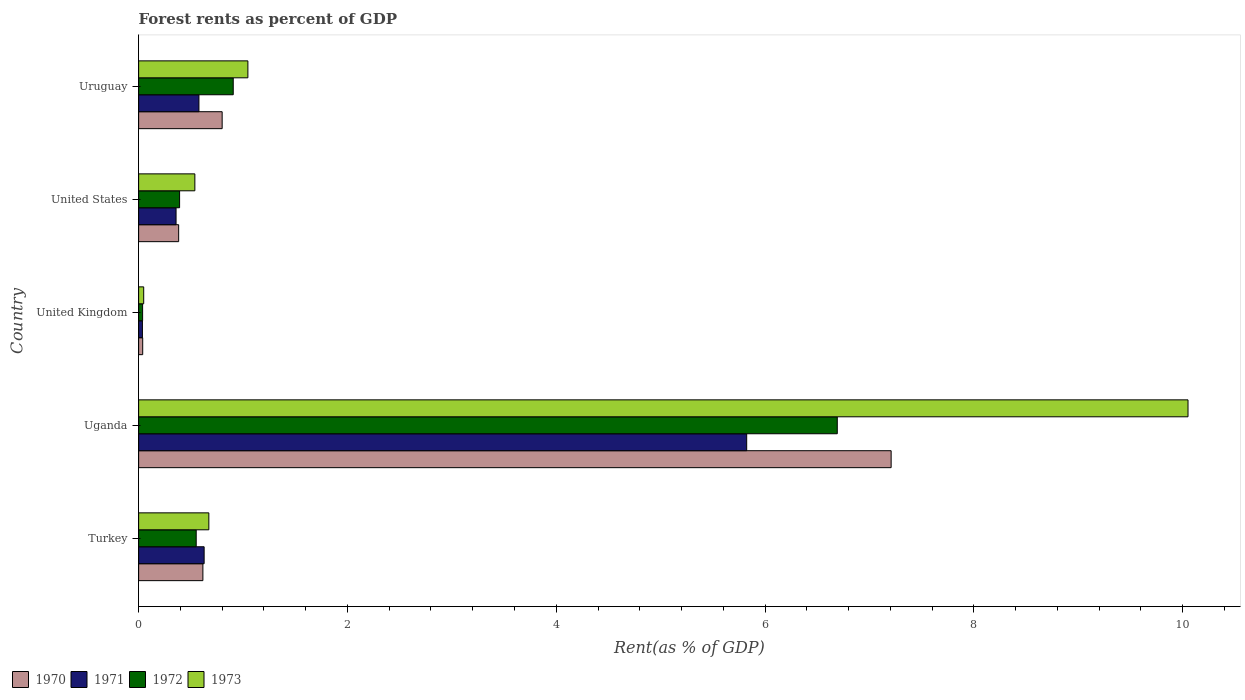How many different coloured bars are there?
Ensure brevity in your answer.  4. How many groups of bars are there?
Provide a succinct answer. 5. Are the number of bars per tick equal to the number of legend labels?
Ensure brevity in your answer.  Yes. Are the number of bars on each tick of the Y-axis equal?
Provide a short and direct response. Yes. How many bars are there on the 4th tick from the top?
Your answer should be compact. 4. How many bars are there on the 3rd tick from the bottom?
Keep it short and to the point. 4. What is the forest rent in 1973 in United Kingdom?
Provide a short and direct response. 0.05. Across all countries, what is the maximum forest rent in 1970?
Your answer should be compact. 7.21. Across all countries, what is the minimum forest rent in 1973?
Your answer should be compact. 0.05. In which country was the forest rent in 1971 maximum?
Your answer should be compact. Uganda. What is the total forest rent in 1973 in the graph?
Keep it short and to the point. 12.36. What is the difference between the forest rent in 1971 in United Kingdom and that in United States?
Ensure brevity in your answer.  -0.32. What is the difference between the forest rent in 1970 in United States and the forest rent in 1973 in Uruguay?
Offer a terse response. -0.66. What is the average forest rent in 1973 per country?
Offer a terse response. 2.47. What is the difference between the forest rent in 1970 and forest rent in 1972 in Uruguay?
Provide a short and direct response. -0.11. In how many countries, is the forest rent in 1971 greater than 7.6 %?
Offer a very short reply. 0. What is the ratio of the forest rent in 1971 in Uganda to that in United States?
Your answer should be compact. 16.24. What is the difference between the highest and the second highest forest rent in 1970?
Keep it short and to the point. 6.41. What is the difference between the highest and the lowest forest rent in 1970?
Keep it short and to the point. 7.17. Is it the case that in every country, the sum of the forest rent in 1970 and forest rent in 1971 is greater than the forest rent in 1973?
Provide a succinct answer. Yes. What is the difference between two consecutive major ticks on the X-axis?
Offer a terse response. 2. Are the values on the major ticks of X-axis written in scientific E-notation?
Provide a succinct answer. No. Where does the legend appear in the graph?
Your answer should be compact. Bottom left. How many legend labels are there?
Provide a succinct answer. 4. How are the legend labels stacked?
Your answer should be compact. Horizontal. What is the title of the graph?
Keep it short and to the point. Forest rents as percent of GDP. What is the label or title of the X-axis?
Offer a very short reply. Rent(as % of GDP). What is the Rent(as % of GDP) in 1970 in Turkey?
Give a very brief answer. 0.62. What is the Rent(as % of GDP) of 1971 in Turkey?
Offer a terse response. 0.63. What is the Rent(as % of GDP) of 1972 in Turkey?
Provide a succinct answer. 0.55. What is the Rent(as % of GDP) in 1973 in Turkey?
Your answer should be very brief. 0.67. What is the Rent(as % of GDP) of 1970 in Uganda?
Make the answer very short. 7.21. What is the Rent(as % of GDP) of 1971 in Uganda?
Give a very brief answer. 5.82. What is the Rent(as % of GDP) of 1972 in Uganda?
Your answer should be very brief. 6.69. What is the Rent(as % of GDP) of 1973 in Uganda?
Ensure brevity in your answer.  10.05. What is the Rent(as % of GDP) in 1970 in United Kingdom?
Ensure brevity in your answer.  0.04. What is the Rent(as % of GDP) of 1971 in United Kingdom?
Your response must be concise. 0.04. What is the Rent(as % of GDP) in 1972 in United Kingdom?
Your answer should be compact. 0.04. What is the Rent(as % of GDP) in 1973 in United Kingdom?
Ensure brevity in your answer.  0.05. What is the Rent(as % of GDP) in 1970 in United States?
Your answer should be very brief. 0.38. What is the Rent(as % of GDP) of 1971 in United States?
Provide a succinct answer. 0.36. What is the Rent(as % of GDP) in 1972 in United States?
Your answer should be compact. 0.39. What is the Rent(as % of GDP) in 1973 in United States?
Ensure brevity in your answer.  0.54. What is the Rent(as % of GDP) of 1970 in Uruguay?
Keep it short and to the point. 0.8. What is the Rent(as % of GDP) in 1971 in Uruguay?
Ensure brevity in your answer.  0.58. What is the Rent(as % of GDP) of 1972 in Uruguay?
Offer a terse response. 0.91. What is the Rent(as % of GDP) of 1973 in Uruguay?
Your answer should be compact. 1.05. Across all countries, what is the maximum Rent(as % of GDP) of 1970?
Offer a very short reply. 7.21. Across all countries, what is the maximum Rent(as % of GDP) in 1971?
Offer a very short reply. 5.82. Across all countries, what is the maximum Rent(as % of GDP) in 1972?
Ensure brevity in your answer.  6.69. Across all countries, what is the maximum Rent(as % of GDP) of 1973?
Ensure brevity in your answer.  10.05. Across all countries, what is the minimum Rent(as % of GDP) of 1970?
Offer a terse response. 0.04. Across all countries, what is the minimum Rent(as % of GDP) in 1971?
Your answer should be very brief. 0.04. Across all countries, what is the minimum Rent(as % of GDP) in 1972?
Provide a short and direct response. 0.04. Across all countries, what is the minimum Rent(as % of GDP) of 1973?
Give a very brief answer. 0.05. What is the total Rent(as % of GDP) of 1970 in the graph?
Your answer should be very brief. 9.04. What is the total Rent(as % of GDP) of 1971 in the graph?
Offer a terse response. 7.42. What is the total Rent(as % of GDP) of 1972 in the graph?
Make the answer very short. 8.58. What is the total Rent(as % of GDP) of 1973 in the graph?
Offer a terse response. 12.36. What is the difference between the Rent(as % of GDP) of 1970 in Turkey and that in Uganda?
Offer a very short reply. -6.59. What is the difference between the Rent(as % of GDP) in 1971 in Turkey and that in Uganda?
Your answer should be very brief. -5.2. What is the difference between the Rent(as % of GDP) in 1972 in Turkey and that in Uganda?
Offer a terse response. -6.14. What is the difference between the Rent(as % of GDP) of 1973 in Turkey and that in Uganda?
Give a very brief answer. -9.38. What is the difference between the Rent(as % of GDP) of 1970 in Turkey and that in United Kingdom?
Your response must be concise. 0.58. What is the difference between the Rent(as % of GDP) of 1971 in Turkey and that in United Kingdom?
Offer a very short reply. 0.59. What is the difference between the Rent(as % of GDP) in 1972 in Turkey and that in United Kingdom?
Provide a succinct answer. 0.51. What is the difference between the Rent(as % of GDP) of 1973 in Turkey and that in United Kingdom?
Ensure brevity in your answer.  0.62. What is the difference between the Rent(as % of GDP) in 1970 in Turkey and that in United States?
Offer a very short reply. 0.23. What is the difference between the Rent(as % of GDP) in 1971 in Turkey and that in United States?
Your answer should be compact. 0.27. What is the difference between the Rent(as % of GDP) of 1972 in Turkey and that in United States?
Your answer should be compact. 0.16. What is the difference between the Rent(as % of GDP) in 1973 in Turkey and that in United States?
Offer a terse response. 0.13. What is the difference between the Rent(as % of GDP) in 1970 in Turkey and that in Uruguay?
Give a very brief answer. -0.18. What is the difference between the Rent(as % of GDP) in 1971 in Turkey and that in Uruguay?
Provide a succinct answer. 0.05. What is the difference between the Rent(as % of GDP) in 1972 in Turkey and that in Uruguay?
Offer a terse response. -0.35. What is the difference between the Rent(as % of GDP) of 1973 in Turkey and that in Uruguay?
Your response must be concise. -0.37. What is the difference between the Rent(as % of GDP) of 1970 in Uganda and that in United Kingdom?
Provide a succinct answer. 7.17. What is the difference between the Rent(as % of GDP) in 1971 in Uganda and that in United Kingdom?
Offer a terse response. 5.79. What is the difference between the Rent(as % of GDP) of 1972 in Uganda and that in United Kingdom?
Your answer should be compact. 6.65. What is the difference between the Rent(as % of GDP) of 1973 in Uganda and that in United Kingdom?
Give a very brief answer. 10. What is the difference between the Rent(as % of GDP) of 1970 in Uganda and that in United States?
Keep it short and to the point. 6.82. What is the difference between the Rent(as % of GDP) in 1971 in Uganda and that in United States?
Your response must be concise. 5.47. What is the difference between the Rent(as % of GDP) in 1972 in Uganda and that in United States?
Provide a short and direct response. 6.3. What is the difference between the Rent(as % of GDP) in 1973 in Uganda and that in United States?
Offer a terse response. 9.51. What is the difference between the Rent(as % of GDP) in 1970 in Uganda and that in Uruguay?
Your answer should be very brief. 6.41. What is the difference between the Rent(as % of GDP) of 1971 in Uganda and that in Uruguay?
Give a very brief answer. 5.25. What is the difference between the Rent(as % of GDP) of 1972 in Uganda and that in Uruguay?
Offer a very short reply. 5.79. What is the difference between the Rent(as % of GDP) in 1973 in Uganda and that in Uruguay?
Keep it short and to the point. 9. What is the difference between the Rent(as % of GDP) in 1970 in United Kingdom and that in United States?
Your answer should be compact. -0.34. What is the difference between the Rent(as % of GDP) in 1971 in United Kingdom and that in United States?
Offer a terse response. -0.32. What is the difference between the Rent(as % of GDP) of 1972 in United Kingdom and that in United States?
Provide a succinct answer. -0.35. What is the difference between the Rent(as % of GDP) in 1973 in United Kingdom and that in United States?
Provide a succinct answer. -0.49. What is the difference between the Rent(as % of GDP) of 1970 in United Kingdom and that in Uruguay?
Offer a terse response. -0.76. What is the difference between the Rent(as % of GDP) of 1971 in United Kingdom and that in Uruguay?
Ensure brevity in your answer.  -0.54. What is the difference between the Rent(as % of GDP) in 1972 in United Kingdom and that in Uruguay?
Make the answer very short. -0.87. What is the difference between the Rent(as % of GDP) in 1973 in United Kingdom and that in Uruguay?
Give a very brief answer. -1. What is the difference between the Rent(as % of GDP) of 1970 in United States and that in Uruguay?
Provide a succinct answer. -0.42. What is the difference between the Rent(as % of GDP) in 1971 in United States and that in Uruguay?
Ensure brevity in your answer.  -0.22. What is the difference between the Rent(as % of GDP) in 1972 in United States and that in Uruguay?
Keep it short and to the point. -0.51. What is the difference between the Rent(as % of GDP) of 1973 in United States and that in Uruguay?
Ensure brevity in your answer.  -0.51. What is the difference between the Rent(as % of GDP) of 1970 in Turkey and the Rent(as % of GDP) of 1971 in Uganda?
Offer a very short reply. -5.21. What is the difference between the Rent(as % of GDP) in 1970 in Turkey and the Rent(as % of GDP) in 1972 in Uganda?
Provide a succinct answer. -6.08. What is the difference between the Rent(as % of GDP) of 1970 in Turkey and the Rent(as % of GDP) of 1973 in Uganda?
Your response must be concise. -9.44. What is the difference between the Rent(as % of GDP) of 1971 in Turkey and the Rent(as % of GDP) of 1972 in Uganda?
Make the answer very short. -6.06. What is the difference between the Rent(as % of GDP) in 1971 in Turkey and the Rent(as % of GDP) in 1973 in Uganda?
Your answer should be very brief. -9.42. What is the difference between the Rent(as % of GDP) in 1972 in Turkey and the Rent(as % of GDP) in 1973 in Uganda?
Provide a short and direct response. -9.5. What is the difference between the Rent(as % of GDP) of 1970 in Turkey and the Rent(as % of GDP) of 1971 in United Kingdom?
Your answer should be compact. 0.58. What is the difference between the Rent(as % of GDP) in 1970 in Turkey and the Rent(as % of GDP) in 1972 in United Kingdom?
Provide a succinct answer. 0.58. What is the difference between the Rent(as % of GDP) of 1970 in Turkey and the Rent(as % of GDP) of 1973 in United Kingdom?
Your answer should be very brief. 0.57. What is the difference between the Rent(as % of GDP) in 1971 in Turkey and the Rent(as % of GDP) in 1972 in United Kingdom?
Offer a very short reply. 0.59. What is the difference between the Rent(as % of GDP) in 1971 in Turkey and the Rent(as % of GDP) in 1973 in United Kingdom?
Provide a succinct answer. 0.58. What is the difference between the Rent(as % of GDP) in 1972 in Turkey and the Rent(as % of GDP) in 1973 in United Kingdom?
Keep it short and to the point. 0.5. What is the difference between the Rent(as % of GDP) in 1970 in Turkey and the Rent(as % of GDP) in 1971 in United States?
Keep it short and to the point. 0.26. What is the difference between the Rent(as % of GDP) of 1970 in Turkey and the Rent(as % of GDP) of 1972 in United States?
Offer a terse response. 0.22. What is the difference between the Rent(as % of GDP) in 1970 in Turkey and the Rent(as % of GDP) in 1973 in United States?
Make the answer very short. 0.08. What is the difference between the Rent(as % of GDP) of 1971 in Turkey and the Rent(as % of GDP) of 1972 in United States?
Provide a succinct answer. 0.23. What is the difference between the Rent(as % of GDP) in 1971 in Turkey and the Rent(as % of GDP) in 1973 in United States?
Provide a short and direct response. 0.09. What is the difference between the Rent(as % of GDP) of 1972 in Turkey and the Rent(as % of GDP) of 1973 in United States?
Your answer should be compact. 0.01. What is the difference between the Rent(as % of GDP) in 1970 in Turkey and the Rent(as % of GDP) in 1971 in Uruguay?
Your answer should be compact. 0.04. What is the difference between the Rent(as % of GDP) of 1970 in Turkey and the Rent(as % of GDP) of 1972 in Uruguay?
Your response must be concise. -0.29. What is the difference between the Rent(as % of GDP) in 1970 in Turkey and the Rent(as % of GDP) in 1973 in Uruguay?
Offer a very short reply. -0.43. What is the difference between the Rent(as % of GDP) of 1971 in Turkey and the Rent(as % of GDP) of 1972 in Uruguay?
Your response must be concise. -0.28. What is the difference between the Rent(as % of GDP) in 1971 in Turkey and the Rent(as % of GDP) in 1973 in Uruguay?
Your answer should be compact. -0.42. What is the difference between the Rent(as % of GDP) in 1972 in Turkey and the Rent(as % of GDP) in 1973 in Uruguay?
Your answer should be very brief. -0.49. What is the difference between the Rent(as % of GDP) in 1970 in Uganda and the Rent(as % of GDP) in 1971 in United Kingdom?
Your response must be concise. 7.17. What is the difference between the Rent(as % of GDP) of 1970 in Uganda and the Rent(as % of GDP) of 1972 in United Kingdom?
Offer a terse response. 7.17. What is the difference between the Rent(as % of GDP) in 1970 in Uganda and the Rent(as % of GDP) in 1973 in United Kingdom?
Keep it short and to the point. 7.16. What is the difference between the Rent(as % of GDP) in 1971 in Uganda and the Rent(as % of GDP) in 1972 in United Kingdom?
Provide a short and direct response. 5.79. What is the difference between the Rent(as % of GDP) in 1971 in Uganda and the Rent(as % of GDP) in 1973 in United Kingdom?
Make the answer very short. 5.78. What is the difference between the Rent(as % of GDP) in 1972 in Uganda and the Rent(as % of GDP) in 1973 in United Kingdom?
Keep it short and to the point. 6.64. What is the difference between the Rent(as % of GDP) in 1970 in Uganda and the Rent(as % of GDP) in 1971 in United States?
Offer a terse response. 6.85. What is the difference between the Rent(as % of GDP) of 1970 in Uganda and the Rent(as % of GDP) of 1972 in United States?
Keep it short and to the point. 6.81. What is the difference between the Rent(as % of GDP) of 1970 in Uganda and the Rent(as % of GDP) of 1973 in United States?
Make the answer very short. 6.67. What is the difference between the Rent(as % of GDP) of 1971 in Uganda and the Rent(as % of GDP) of 1972 in United States?
Offer a terse response. 5.43. What is the difference between the Rent(as % of GDP) in 1971 in Uganda and the Rent(as % of GDP) in 1973 in United States?
Ensure brevity in your answer.  5.29. What is the difference between the Rent(as % of GDP) of 1972 in Uganda and the Rent(as % of GDP) of 1973 in United States?
Ensure brevity in your answer.  6.15. What is the difference between the Rent(as % of GDP) of 1970 in Uganda and the Rent(as % of GDP) of 1971 in Uruguay?
Make the answer very short. 6.63. What is the difference between the Rent(as % of GDP) in 1970 in Uganda and the Rent(as % of GDP) in 1972 in Uruguay?
Your response must be concise. 6.3. What is the difference between the Rent(as % of GDP) in 1970 in Uganda and the Rent(as % of GDP) in 1973 in Uruguay?
Ensure brevity in your answer.  6.16. What is the difference between the Rent(as % of GDP) of 1971 in Uganda and the Rent(as % of GDP) of 1972 in Uruguay?
Your answer should be very brief. 4.92. What is the difference between the Rent(as % of GDP) in 1971 in Uganda and the Rent(as % of GDP) in 1973 in Uruguay?
Your answer should be compact. 4.78. What is the difference between the Rent(as % of GDP) in 1972 in Uganda and the Rent(as % of GDP) in 1973 in Uruguay?
Keep it short and to the point. 5.65. What is the difference between the Rent(as % of GDP) in 1970 in United Kingdom and the Rent(as % of GDP) in 1971 in United States?
Keep it short and to the point. -0.32. What is the difference between the Rent(as % of GDP) of 1970 in United Kingdom and the Rent(as % of GDP) of 1972 in United States?
Keep it short and to the point. -0.35. What is the difference between the Rent(as % of GDP) of 1970 in United Kingdom and the Rent(as % of GDP) of 1973 in United States?
Your answer should be compact. -0.5. What is the difference between the Rent(as % of GDP) of 1971 in United Kingdom and the Rent(as % of GDP) of 1972 in United States?
Keep it short and to the point. -0.36. What is the difference between the Rent(as % of GDP) in 1971 in United Kingdom and the Rent(as % of GDP) in 1973 in United States?
Keep it short and to the point. -0.5. What is the difference between the Rent(as % of GDP) of 1972 in United Kingdom and the Rent(as % of GDP) of 1973 in United States?
Keep it short and to the point. -0.5. What is the difference between the Rent(as % of GDP) in 1970 in United Kingdom and the Rent(as % of GDP) in 1971 in Uruguay?
Your answer should be very brief. -0.54. What is the difference between the Rent(as % of GDP) in 1970 in United Kingdom and the Rent(as % of GDP) in 1972 in Uruguay?
Make the answer very short. -0.87. What is the difference between the Rent(as % of GDP) in 1970 in United Kingdom and the Rent(as % of GDP) in 1973 in Uruguay?
Provide a succinct answer. -1.01. What is the difference between the Rent(as % of GDP) of 1971 in United Kingdom and the Rent(as % of GDP) of 1972 in Uruguay?
Ensure brevity in your answer.  -0.87. What is the difference between the Rent(as % of GDP) in 1971 in United Kingdom and the Rent(as % of GDP) in 1973 in Uruguay?
Your answer should be compact. -1.01. What is the difference between the Rent(as % of GDP) of 1972 in United Kingdom and the Rent(as % of GDP) of 1973 in Uruguay?
Ensure brevity in your answer.  -1.01. What is the difference between the Rent(as % of GDP) in 1970 in United States and the Rent(as % of GDP) in 1971 in Uruguay?
Your answer should be compact. -0.19. What is the difference between the Rent(as % of GDP) in 1970 in United States and the Rent(as % of GDP) in 1972 in Uruguay?
Provide a short and direct response. -0.52. What is the difference between the Rent(as % of GDP) of 1970 in United States and the Rent(as % of GDP) of 1973 in Uruguay?
Offer a very short reply. -0.66. What is the difference between the Rent(as % of GDP) of 1971 in United States and the Rent(as % of GDP) of 1972 in Uruguay?
Keep it short and to the point. -0.55. What is the difference between the Rent(as % of GDP) of 1971 in United States and the Rent(as % of GDP) of 1973 in Uruguay?
Ensure brevity in your answer.  -0.69. What is the difference between the Rent(as % of GDP) in 1972 in United States and the Rent(as % of GDP) in 1973 in Uruguay?
Your response must be concise. -0.65. What is the average Rent(as % of GDP) in 1970 per country?
Provide a succinct answer. 1.81. What is the average Rent(as % of GDP) of 1971 per country?
Make the answer very short. 1.48. What is the average Rent(as % of GDP) in 1972 per country?
Provide a short and direct response. 1.72. What is the average Rent(as % of GDP) of 1973 per country?
Give a very brief answer. 2.47. What is the difference between the Rent(as % of GDP) in 1970 and Rent(as % of GDP) in 1971 in Turkey?
Offer a very short reply. -0.01. What is the difference between the Rent(as % of GDP) in 1970 and Rent(as % of GDP) in 1972 in Turkey?
Your response must be concise. 0.06. What is the difference between the Rent(as % of GDP) of 1970 and Rent(as % of GDP) of 1973 in Turkey?
Provide a succinct answer. -0.06. What is the difference between the Rent(as % of GDP) of 1971 and Rent(as % of GDP) of 1972 in Turkey?
Provide a short and direct response. 0.08. What is the difference between the Rent(as % of GDP) in 1971 and Rent(as % of GDP) in 1973 in Turkey?
Your answer should be compact. -0.05. What is the difference between the Rent(as % of GDP) of 1972 and Rent(as % of GDP) of 1973 in Turkey?
Ensure brevity in your answer.  -0.12. What is the difference between the Rent(as % of GDP) in 1970 and Rent(as % of GDP) in 1971 in Uganda?
Offer a very short reply. 1.38. What is the difference between the Rent(as % of GDP) of 1970 and Rent(as % of GDP) of 1972 in Uganda?
Provide a short and direct response. 0.52. What is the difference between the Rent(as % of GDP) in 1970 and Rent(as % of GDP) in 1973 in Uganda?
Give a very brief answer. -2.84. What is the difference between the Rent(as % of GDP) of 1971 and Rent(as % of GDP) of 1972 in Uganda?
Your response must be concise. -0.87. What is the difference between the Rent(as % of GDP) in 1971 and Rent(as % of GDP) in 1973 in Uganda?
Your answer should be very brief. -4.23. What is the difference between the Rent(as % of GDP) in 1972 and Rent(as % of GDP) in 1973 in Uganda?
Keep it short and to the point. -3.36. What is the difference between the Rent(as % of GDP) of 1970 and Rent(as % of GDP) of 1971 in United Kingdom?
Ensure brevity in your answer.  0. What is the difference between the Rent(as % of GDP) in 1970 and Rent(as % of GDP) in 1972 in United Kingdom?
Offer a terse response. 0. What is the difference between the Rent(as % of GDP) of 1970 and Rent(as % of GDP) of 1973 in United Kingdom?
Your answer should be very brief. -0.01. What is the difference between the Rent(as % of GDP) of 1971 and Rent(as % of GDP) of 1972 in United Kingdom?
Provide a short and direct response. -0. What is the difference between the Rent(as % of GDP) in 1971 and Rent(as % of GDP) in 1973 in United Kingdom?
Your response must be concise. -0.01. What is the difference between the Rent(as % of GDP) in 1972 and Rent(as % of GDP) in 1973 in United Kingdom?
Keep it short and to the point. -0.01. What is the difference between the Rent(as % of GDP) in 1970 and Rent(as % of GDP) in 1971 in United States?
Ensure brevity in your answer.  0.02. What is the difference between the Rent(as % of GDP) of 1970 and Rent(as % of GDP) of 1972 in United States?
Offer a very short reply. -0.01. What is the difference between the Rent(as % of GDP) in 1970 and Rent(as % of GDP) in 1973 in United States?
Provide a succinct answer. -0.16. What is the difference between the Rent(as % of GDP) of 1971 and Rent(as % of GDP) of 1972 in United States?
Your response must be concise. -0.03. What is the difference between the Rent(as % of GDP) of 1971 and Rent(as % of GDP) of 1973 in United States?
Provide a short and direct response. -0.18. What is the difference between the Rent(as % of GDP) in 1972 and Rent(as % of GDP) in 1973 in United States?
Ensure brevity in your answer.  -0.15. What is the difference between the Rent(as % of GDP) in 1970 and Rent(as % of GDP) in 1971 in Uruguay?
Provide a succinct answer. 0.22. What is the difference between the Rent(as % of GDP) in 1970 and Rent(as % of GDP) in 1972 in Uruguay?
Keep it short and to the point. -0.11. What is the difference between the Rent(as % of GDP) of 1970 and Rent(as % of GDP) of 1973 in Uruguay?
Provide a short and direct response. -0.25. What is the difference between the Rent(as % of GDP) in 1971 and Rent(as % of GDP) in 1972 in Uruguay?
Give a very brief answer. -0.33. What is the difference between the Rent(as % of GDP) of 1971 and Rent(as % of GDP) of 1973 in Uruguay?
Your response must be concise. -0.47. What is the difference between the Rent(as % of GDP) of 1972 and Rent(as % of GDP) of 1973 in Uruguay?
Your response must be concise. -0.14. What is the ratio of the Rent(as % of GDP) in 1970 in Turkey to that in Uganda?
Ensure brevity in your answer.  0.09. What is the ratio of the Rent(as % of GDP) of 1971 in Turkey to that in Uganda?
Provide a succinct answer. 0.11. What is the ratio of the Rent(as % of GDP) in 1972 in Turkey to that in Uganda?
Provide a short and direct response. 0.08. What is the ratio of the Rent(as % of GDP) of 1973 in Turkey to that in Uganda?
Offer a terse response. 0.07. What is the ratio of the Rent(as % of GDP) in 1970 in Turkey to that in United Kingdom?
Your answer should be very brief. 15.78. What is the ratio of the Rent(as % of GDP) in 1971 in Turkey to that in United Kingdom?
Provide a succinct answer. 17.29. What is the ratio of the Rent(as % of GDP) of 1972 in Turkey to that in United Kingdom?
Your answer should be compact. 14.49. What is the ratio of the Rent(as % of GDP) of 1973 in Turkey to that in United Kingdom?
Your answer should be compact. 13.83. What is the ratio of the Rent(as % of GDP) of 1970 in Turkey to that in United States?
Offer a terse response. 1.61. What is the ratio of the Rent(as % of GDP) in 1971 in Turkey to that in United States?
Ensure brevity in your answer.  1.75. What is the ratio of the Rent(as % of GDP) of 1972 in Turkey to that in United States?
Offer a very short reply. 1.41. What is the ratio of the Rent(as % of GDP) of 1973 in Turkey to that in United States?
Provide a short and direct response. 1.25. What is the ratio of the Rent(as % of GDP) in 1970 in Turkey to that in Uruguay?
Offer a very short reply. 0.77. What is the ratio of the Rent(as % of GDP) of 1971 in Turkey to that in Uruguay?
Your response must be concise. 1.09. What is the ratio of the Rent(as % of GDP) of 1972 in Turkey to that in Uruguay?
Offer a very short reply. 0.61. What is the ratio of the Rent(as % of GDP) in 1973 in Turkey to that in Uruguay?
Provide a succinct answer. 0.64. What is the ratio of the Rent(as % of GDP) of 1970 in Uganda to that in United Kingdom?
Your response must be concise. 184.81. What is the ratio of the Rent(as % of GDP) of 1971 in Uganda to that in United Kingdom?
Provide a succinct answer. 160.46. What is the ratio of the Rent(as % of GDP) in 1972 in Uganda to that in United Kingdom?
Your answer should be compact. 175.86. What is the ratio of the Rent(as % of GDP) in 1973 in Uganda to that in United Kingdom?
Ensure brevity in your answer.  206.75. What is the ratio of the Rent(as % of GDP) of 1970 in Uganda to that in United States?
Offer a terse response. 18.8. What is the ratio of the Rent(as % of GDP) in 1971 in Uganda to that in United States?
Provide a succinct answer. 16.24. What is the ratio of the Rent(as % of GDP) of 1972 in Uganda to that in United States?
Provide a short and direct response. 17.05. What is the ratio of the Rent(as % of GDP) in 1973 in Uganda to that in United States?
Offer a very short reply. 18.66. What is the ratio of the Rent(as % of GDP) of 1970 in Uganda to that in Uruguay?
Offer a terse response. 9.01. What is the ratio of the Rent(as % of GDP) of 1971 in Uganda to that in Uruguay?
Your answer should be compact. 10.08. What is the ratio of the Rent(as % of GDP) of 1972 in Uganda to that in Uruguay?
Your answer should be very brief. 7.38. What is the ratio of the Rent(as % of GDP) of 1973 in Uganda to that in Uruguay?
Provide a short and direct response. 9.6. What is the ratio of the Rent(as % of GDP) of 1970 in United Kingdom to that in United States?
Make the answer very short. 0.1. What is the ratio of the Rent(as % of GDP) in 1971 in United Kingdom to that in United States?
Offer a very short reply. 0.1. What is the ratio of the Rent(as % of GDP) in 1972 in United Kingdom to that in United States?
Offer a very short reply. 0.1. What is the ratio of the Rent(as % of GDP) of 1973 in United Kingdom to that in United States?
Offer a terse response. 0.09. What is the ratio of the Rent(as % of GDP) in 1970 in United Kingdom to that in Uruguay?
Keep it short and to the point. 0.05. What is the ratio of the Rent(as % of GDP) of 1971 in United Kingdom to that in Uruguay?
Your response must be concise. 0.06. What is the ratio of the Rent(as % of GDP) in 1972 in United Kingdom to that in Uruguay?
Offer a terse response. 0.04. What is the ratio of the Rent(as % of GDP) of 1973 in United Kingdom to that in Uruguay?
Offer a terse response. 0.05. What is the ratio of the Rent(as % of GDP) of 1970 in United States to that in Uruguay?
Make the answer very short. 0.48. What is the ratio of the Rent(as % of GDP) in 1971 in United States to that in Uruguay?
Offer a terse response. 0.62. What is the ratio of the Rent(as % of GDP) of 1972 in United States to that in Uruguay?
Offer a terse response. 0.43. What is the ratio of the Rent(as % of GDP) of 1973 in United States to that in Uruguay?
Your answer should be very brief. 0.51. What is the difference between the highest and the second highest Rent(as % of GDP) of 1970?
Ensure brevity in your answer.  6.41. What is the difference between the highest and the second highest Rent(as % of GDP) in 1971?
Your answer should be very brief. 5.2. What is the difference between the highest and the second highest Rent(as % of GDP) of 1972?
Ensure brevity in your answer.  5.79. What is the difference between the highest and the second highest Rent(as % of GDP) in 1973?
Offer a terse response. 9. What is the difference between the highest and the lowest Rent(as % of GDP) of 1970?
Make the answer very short. 7.17. What is the difference between the highest and the lowest Rent(as % of GDP) of 1971?
Your answer should be compact. 5.79. What is the difference between the highest and the lowest Rent(as % of GDP) in 1972?
Give a very brief answer. 6.65. What is the difference between the highest and the lowest Rent(as % of GDP) in 1973?
Provide a short and direct response. 10. 